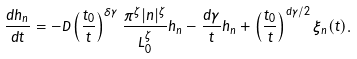<formula> <loc_0><loc_0><loc_500><loc_500>\frac { d h _ { n } } { d t } = - D \left ( \frac { t _ { 0 } } { t } \right ) ^ { \delta \gamma } \frac { \pi ^ { \zeta } | n | ^ { \zeta } } { L _ { 0 } ^ { \zeta } } h _ { n } - \frac { d \gamma } { t } h _ { n } + \left ( \frac { t _ { 0 } } { t } \right ) ^ { d \gamma / 2 } \xi _ { n } ( t ) .</formula> 